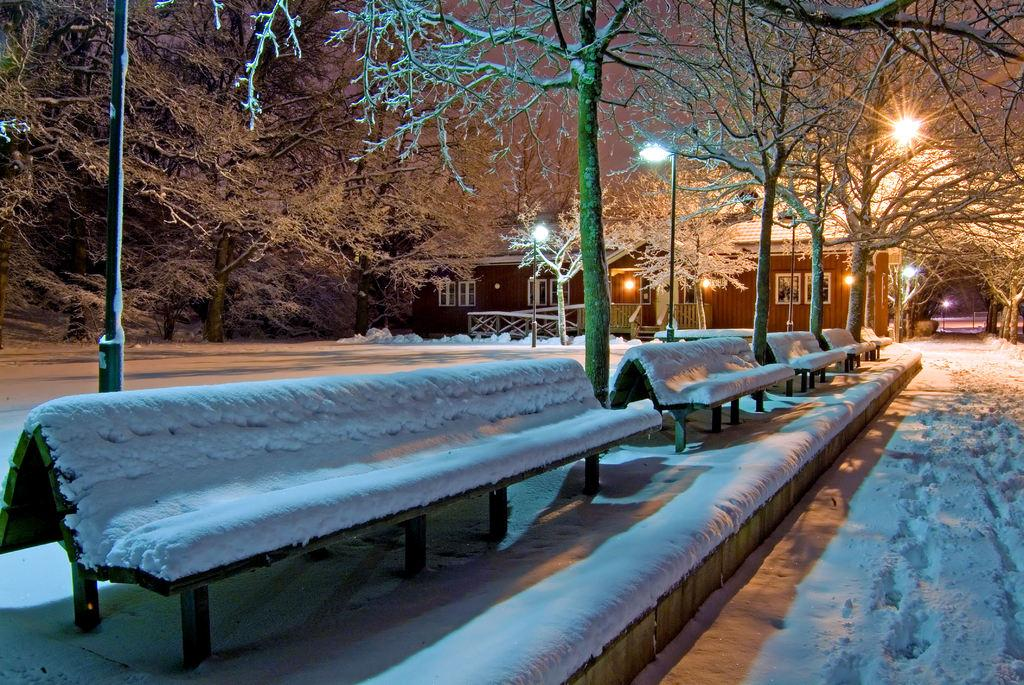What type of weather condition is depicted in the image? There is snow in the image, indicating a winter scene. What objects are covered with snow in the image? There are benches covered with snow in the image. What type of structure can be seen in the image? There is a building in the image. What type of lighting is present in the image? There are light poles in the image. What type of vegetation is present in the image? There are trees in the image. What type of poison is present in the image? There is no poison present in the image; it features a snowy scene with benches, a building, light poles, and trees. 